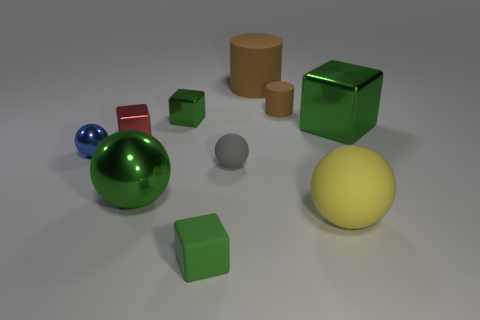Subtract all red cylinders. How many green blocks are left? 3 Subtract all cubes. How many objects are left? 6 Subtract all large brown cylinders. Subtract all large gray metallic spheres. How many objects are left? 9 Add 3 small rubber things. How many small rubber things are left? 6 Add 6 small yellow balls. How many small yellow balls exist? 6 Subtract 0 brown balls. How many objects are left? 10 